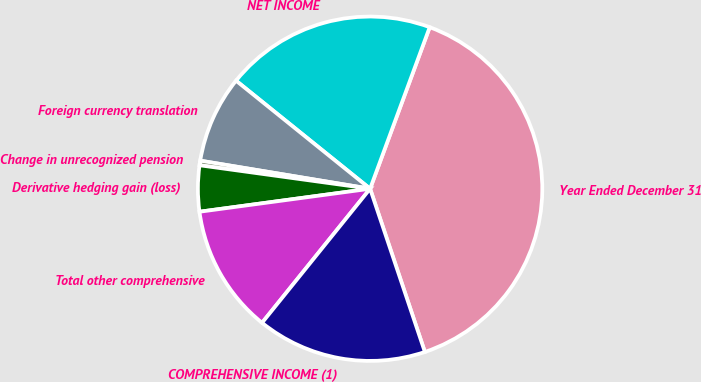<chart> <loc_0><loc_0><loc_500><loc_500><pie_chart><fcel>Year Ended December 31<fcel>NET INCOME<fcel>Foreign currency translation<fcel>Change in unrecognized pension<fcel>Derivative hedging gain (loss)<fcel>Total other comprehensive<fcel>COMPREHENSIVE INCOME (1)<nl><fcel>39.22%<fcel>19.83%<fcel>8.19%<fcel>0.43%<fcel>4.31%<fcel>12.07%<fcel>15.95%<nl></chart> 